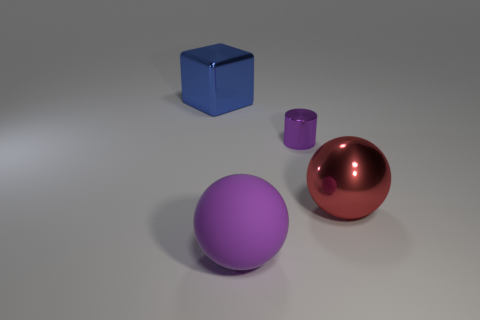Do the large red ball and the tiny purple object have the same material? It's challenging to ascertain the exact materials of the large red ball and the tiny purple object solely through a visual inspection of an image. However, based on the reflective properties observed, both appear to be made of a material with a similar glossy finish, possibly indicating a type of plastic or polished metal. 